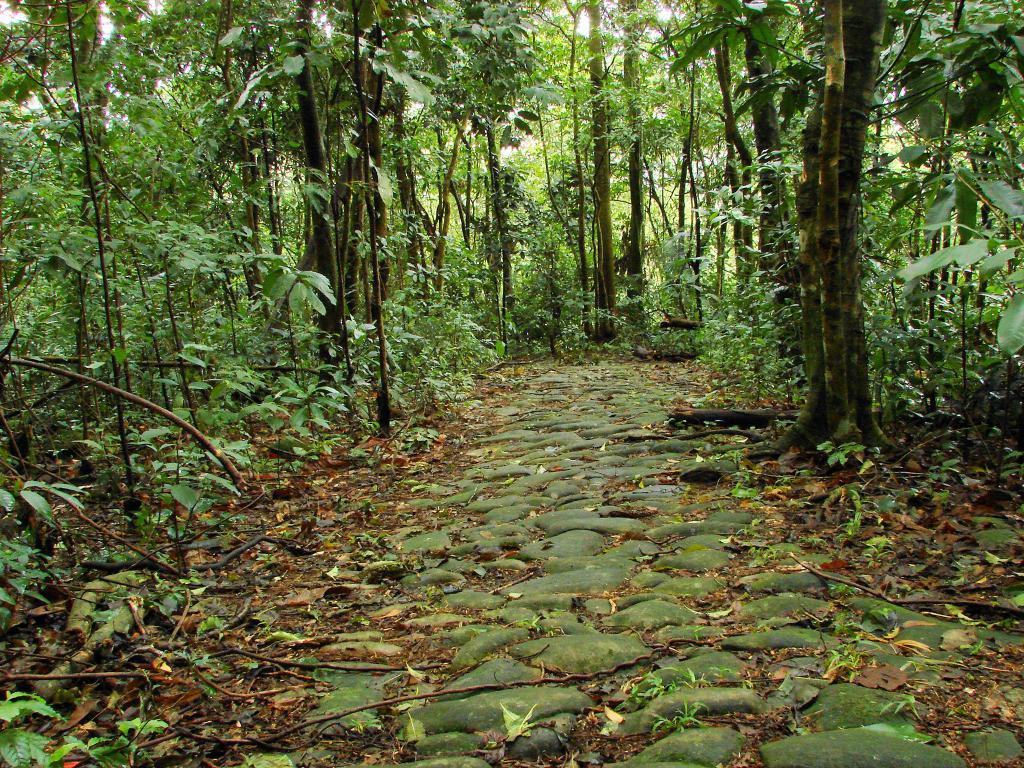What type of pathway is visible in the image? There is a stone pathway in the image. What can be seen on either side of the pathway? Trees and plants are present on either side of the pathway. What type of handshake can be seen between the trees in the image? There is no handshake present in the image, as trees do not have hands or the ability to engage in a handshake. 